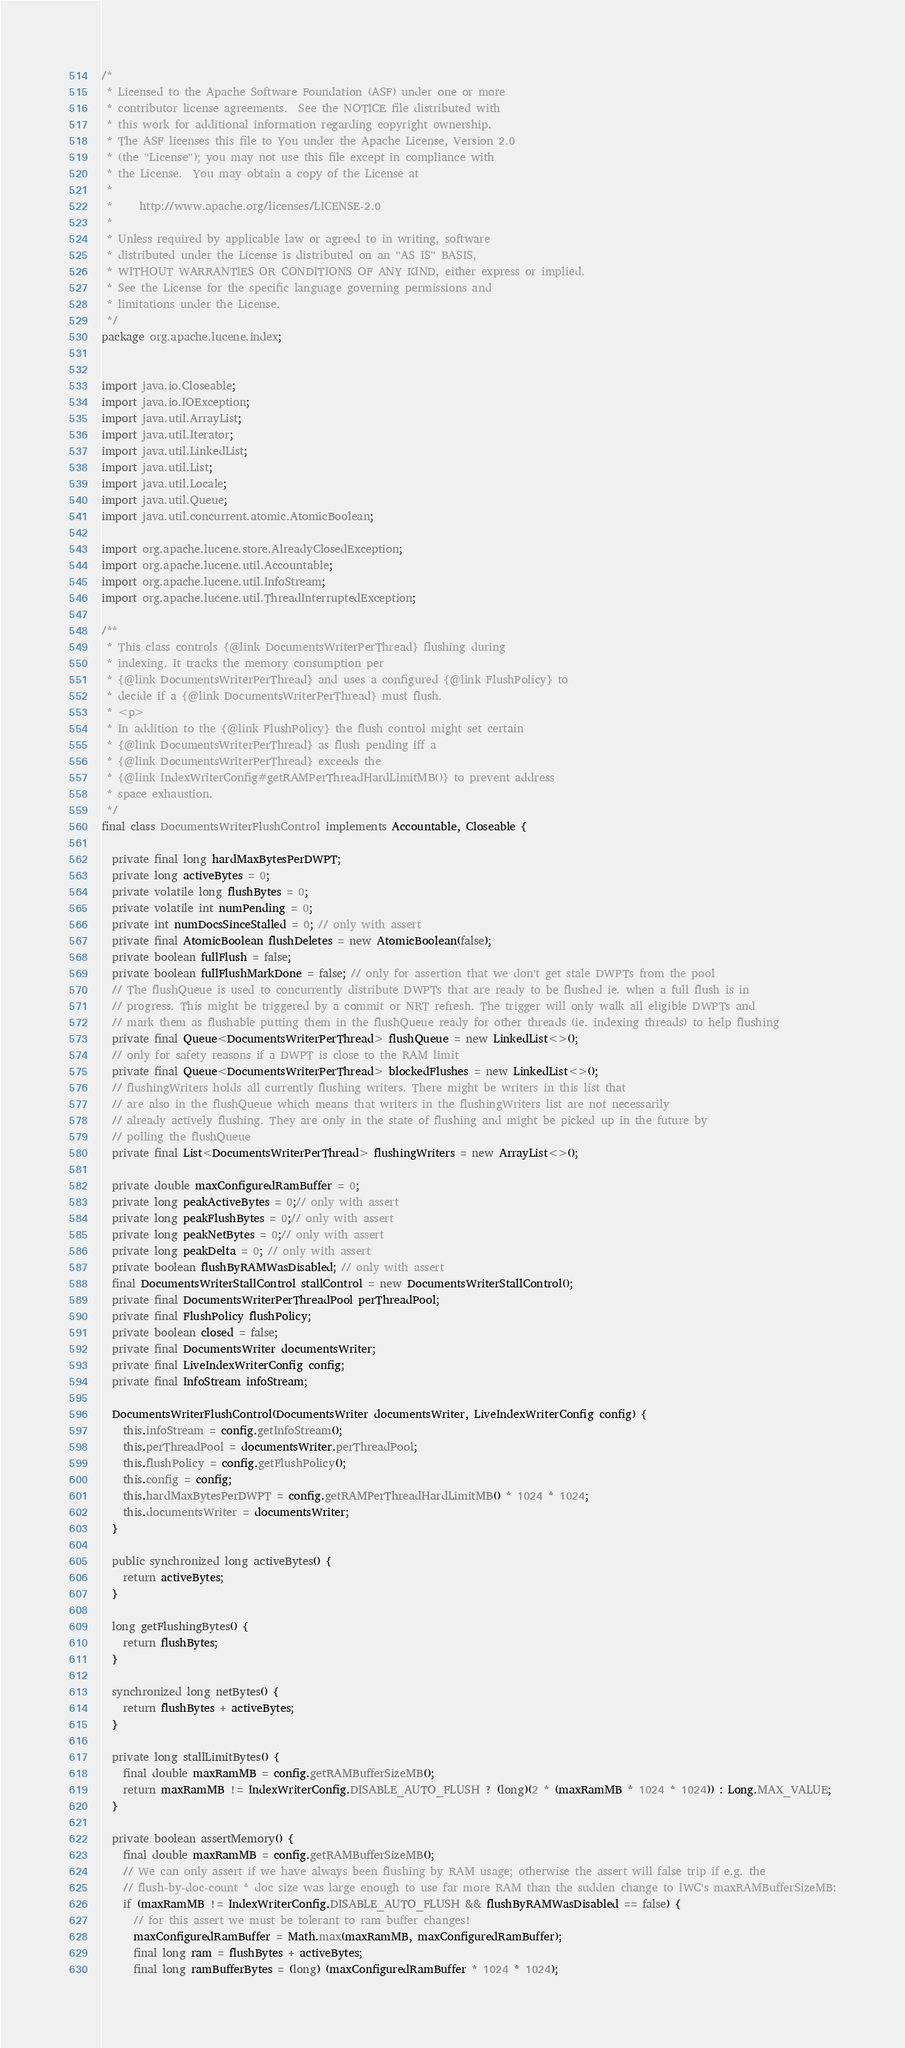<code> <loc_0><loc_0><loc_500><loc_500><_Java_>/*
 * Licensed to the Apache Software Foundation (ASF) under one or more
 * contributor license agreements.  See the NOTICE file distributed with
 * this work for additional information regarding copyright ownership.
 * The ASF licenses this file to You under the Apache License, Version 2.0
 * (the "License"); you may not use this file except in compliance with
 * the License.  You may obtain a copy of the License at
 *
 *     http://www.apache.org/licenses/LICENSE-2.0
 *
 * Unless required by applicable law or agreed to in writing, software
 * distributed under the License is distributed on an "AS IS" BASIS,
 * WITHOUT WARRANTIES OR CONDITIONS OF ANY KIND, either express or implied.
 * See the License for the specific language governing permissions and
 * limitations under the License.
 */
package org.apache.lucene.index;


import java.io.Closeable;
import java.io.IOException;
import java.util.ArrayList;
import java.util.Iterator;
import java.util.LinkedList;
import java.util.List;
import java.util.Locale;
import java.util.Queue;
import java.util.concurrent.atomic.AtomicBoolean;

import org.apache.lucene.store.AlreadyClosedException;
import org.apache.lucene.util.Accountable;
import org.apache.lucene.util.InfoStream;
import org.apache.lucene.util.ThreadInterruptedException;

/**
 * This class controls {@link DocumentsWriterPerThread} flushing during
 * indexing. It tracks the memory consumption per
 * {@link DocumentsWriterPerThread} and uses a configured {@link FlushPolicy} to
 * decide if a {@link DocumentsWriterPerThread} must flush.
 * <p>
 * In addition to the {@link FlushPolicy} the flush control might set certain
 * {@link DocumentsWriterPerThread} as flush pending iff a
 * {@link DocumentsWriterPerThread} exceeds the
 * {@link IndexWriterConfig#getRAMPerThreadHardLimitMB()} to prevent address
 * space exhaustion.
 */
final class DocumentsWriterFlushControl implements Accountable, Closeable {

  private final long hardMaxBytesPerDWPT;
  private long activeBytes = 0;
  private volatile long flushBytes = 0;
  private volatile int numPending = 0;
  private int numDocsSinceStalled = 0; // only with assert
  private final AtomicBoolean flushDeletes = new AtomicBoolean(false);
  private boolean fullFlush = false;
  private boolean fullFlushMarkDone = false; // only for assertion that we don't get stale DWPTs from the pool
  // The flushQueue is used to concurrently distribute DWPTs that are ready to be flushed ie. when a full flush is in
  // progress. This might be triggered by a commit or NRT refresh. The trigger will only walk all eligible DWPTs and
  // mark them as flushable putting them in the flushQueue ready for other threads (ie. indexing threads) to help flushing
  private final Queue<DocumentsWriterPerThread> flushQueue = new LinkedList<>();
  // only for safety reasons if a DWPT is close to the RAM limit
  private final Queue<DocumentsWriterPerThread> blockedFlushes = new LinkedList<>();
  // flushingWriters holds all currently flushing writers. There might be writers in this list that
  // are also in the flushQueue which means that writers in the flushingWriters list are not necessarily
  // already actively flushing. They are only in the state of flushing and might be picked up in the future by
  // polling the flushQueue
  private final List<DocumentsWriterPerThread> flushingWriters = new ArrayList<>();

  private double maxConfiguredRamBuffer = 0;
  private long peakActiveBytes = 0;// only with assert
  private long peakFlushBytes = 0;// only with assert
  private long peakNetBytes = 0;// only with assert
  private long peakDelta = 0; // only with assert
  private boolean flushByRAMWasDisabled; // only with assert
  final DocumentsWriterStallControl stallControl = new DocumentsWriterStallControl();
  private final DocumentsWriterPerThreadPool perThreadPool;
  private final FlushPolicy flushPolicy;
  private boolean closed = false;
  private final DocumentsWriter documentsWriter;
  private final LiveIndexWriterConfig config;
  private final InfoStream infoStream;

  DocumentsWriterFlushControl(DocumentsWriter documentsWriter, LiveIndexWriterConfig config) {
    this.infoStream = config.getInfoStream();
    this.perThreadPool = documentsWriter.perThreadPool;
    this.flushPolicy = config.getFlushPolicy();
    this.config = config;
    this.hardMaxBytesPerDWPT = config.getRAMPerThreadHardLimitMB() * 1024 * 1024;
    this.documentsWriter = documentsWriter;
  }

  public synchronized long activeBytes() {
    return activeBytes;
  }

  long getFlushingBytes() {
    return flushBytes;
  }

  synchronized long netBytes() {
    return flushBytes + activeBytes;
  }
  
  private long stallLimitBytes() {
    final double maxRamMB = config.getRAMBufferSizeMB();
    return maxRamMB != IndexWriterConfig.DISABLE_AUTO_FLUSH ? (long)(2 * (maxRamMB * 1024 * 1024)) : Long.MAX_VALUE;
  }
  
  private boolean assertMemory() {
    final double maxRamMB = config.getRAMBufferSizeMB();
    // We can only assert if we have always been flushing by RAM usage; otherwise the assert will false trip if e.g. the
    // flush-by-doc-count * doc size was large enough to use far more RAM than the sudden change to IWC's maxRAMBufferSizeMB:
    if (maxRamMB != IndexWriterConfig.DISABLE_AUTO_FLUSH && flushByRAMWasDisabled == false) {
      // for this assert we must be tolerant to ram buffer changes!
      maxConfiguredRamBuffer = Math.max(maxRamMB, maxConfiguredRamBuffer);
      final long ram = flushBytes + activeBytes;
      final long ramBufferBytes = (long) (maxConfiguredRamBuffer * 1024 * 1024);</code> 